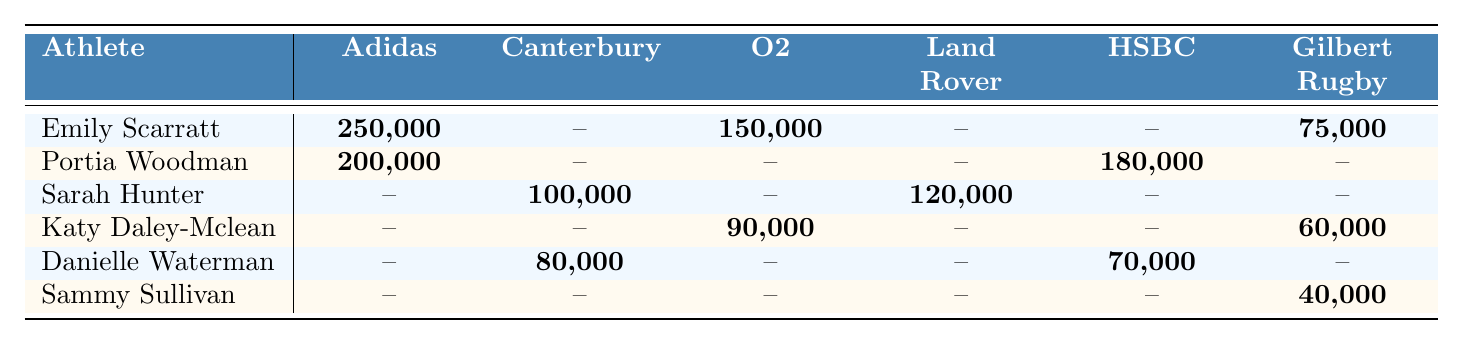What is the highest sponsorship deal received by Emily Scarratt? The table shows that Emily Scarratt has three sponsorship deals. The highest amount is from Adidas at 250,000.
Answer: 250,000 Which athlete has a sponsorship deal with both Canterbury and HSBC? Looking at the table, Sarah Hunter has a deal with Canterbury for 100,000 and Land Rover for 120,000, and Danielle Waterman has deals with Canterbury for 80,000 and HSBC for 70,000. Therefore, the athlete who has both is Danielle Waterman.
Answer: Danielle Waterman How much total sponsorship money does Portia Woodman have? Portia Woodman has two sponsorship deals: 200,000 from Adidas and 180,000 from HSBC. Therefore, the total is 200,000 + 180,000 = 380,000.
Answer: 380,000 Does Sammy Sullivan have any sponsorships with Adidas or O2? According to the table, Sammy Sullivan has a sponsorship only with Gilbert Rugby for 40,000 and does not have sponsorships with Adidas or O2.
Answer: No Which athlete has the highest total sponsorship amount? To find this, we will calculate the total for each athlete: Emily Scarratt: 250,000 + 150,000 + 75,000 = 475,000; Portia Woodman: 200,000 + 180,000 = 380,000; Sarah Hunter: 100,000 + 120,000 = 220,000; Katy Daley-Mclean: 90,000 + 60,000 = 150,000; Danielle Waterman: 80,000 + 70,000 = 150,000; Sammy Sullivan: 40,000. The highest total is 475,000 for Emily Scarratt.
Answer: Emily Scarratt Which sponsorships are unique to Sammy Sullivan? In the table, Sammy Sullivan has only one sponsorship, which is with Gilbert Rugby for 40,000, and no one else has this sponsorship.
Answer: Gilbert Rugby How does the average sponsorship amount of all athletes compare? First, we determine the sponsorship totals as follows: Emily Scarratt has 475,000, Portia Woodman has 380,000, Sarah Hunter has 220,000, Katy Daley-Mclean has 150,000, Danielle Waterman has 150,000, and Sammy Sullivan has 40,000. The total combined is 1,415,000 for 6 athletes; thus, the average is 1,415,000 / 6 = approximately 235,833.
Answer: Approximately 235,833 What is the total amount of sponsorship deals for athletes with deals from Gilbert Rugby? Sammy Sullivan has 40,000 and Emily Scarratt has 75,000 from Gilbert Rugby, giving a total of 40,000 + 75,000 = 115,000.
Answer: 115,000 Is there any athlete without an Adidas sponsorship? Reviewing the table, it is clear that only Portia Woodman and Emily Scarratt have deals with Adidas, while the others do not, therefore yes, several athletes lack this sponsorship.
Answer: Yes, several athletes lack this sponsorship 